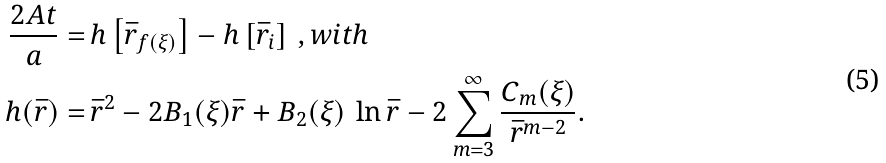Convert formula to latex. <formula><loc_0><loc_0><loc_500><loc_500>\frac { 2 A t } { a } = & \, h \left [ \bar { r } _ { f ( \xi ) } \right ] - h \left [ \bar { r } _ { i } \right ] \, , w i t h \\ h ( \bar { r } ) = & \, \bar { r } ^ { 2 } - 2 B _ { 1 } ( \xi ) \bar { r } + B _ { 2 } ( \xi ) \, \ln { \bar { r } } - 2 \sum _ { m = 3 } ^ { \infty } \frac { C _ { m } ( \xi ) } { \bar { r } ^ { m - 2 } } .</formula> 